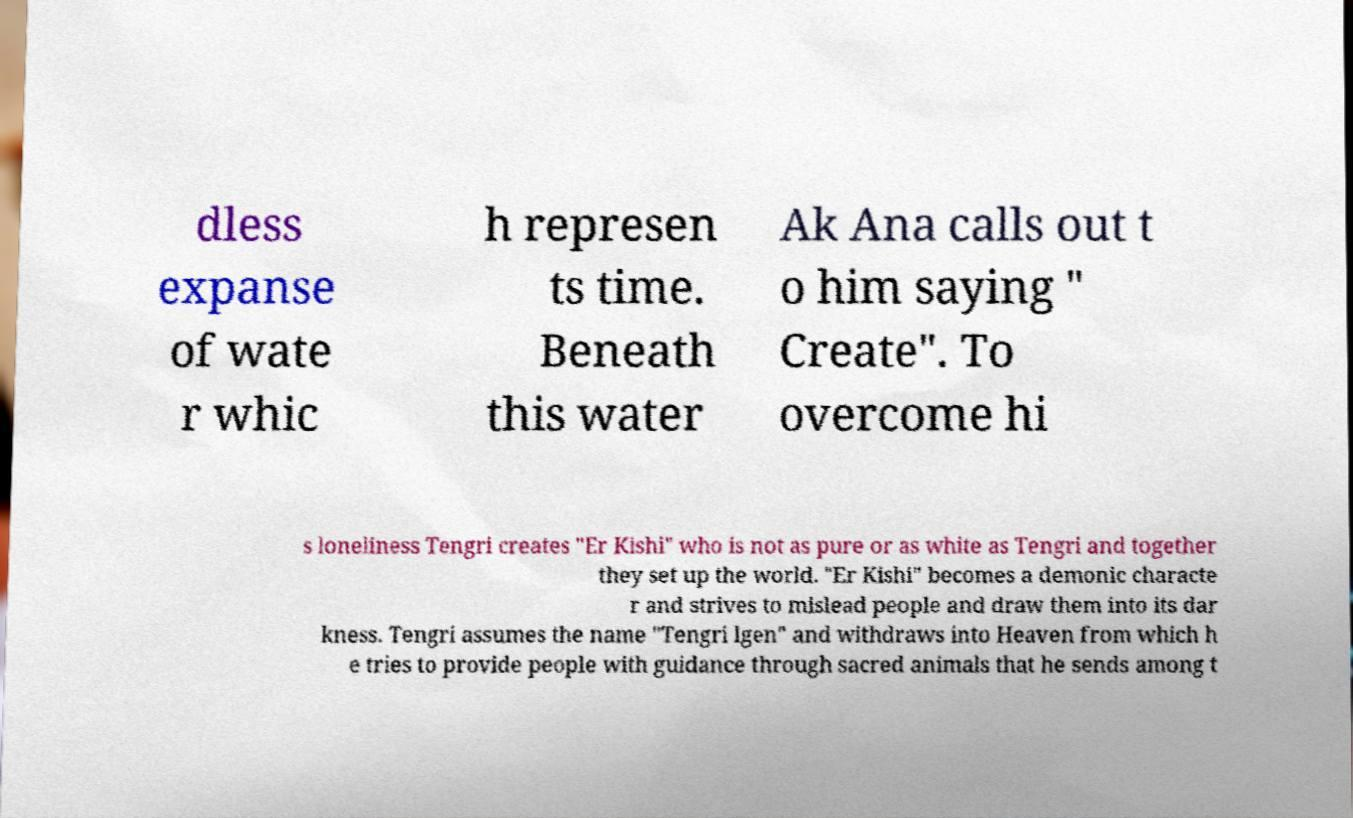Please identify and transcribe the text found in this image. dless expanse of wate r whic h represen ts time. Beneath this water Ak Ana calls out t o him saying " Create". To overcome hi s loneliness Tengri creates "Er Kishi" who is not as pure or as white as Tengri and together they set up the world. "Er Kishi" becomes a demonic characte r and strives to mislead people and draw them into its dar kness. Tengri assumes the name "Tengri lgen" and withdraws into Heaven from which h e tries to provide people with guidance through sacred animals that he sends among t 